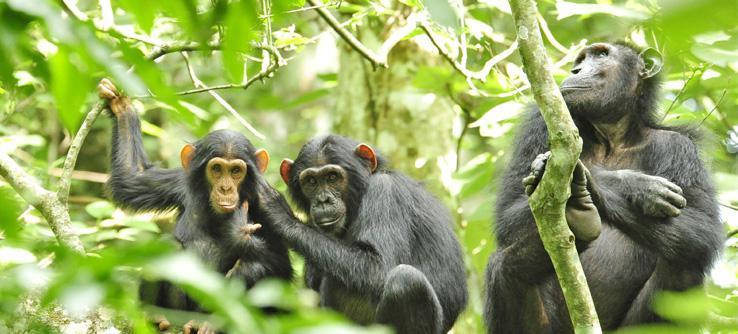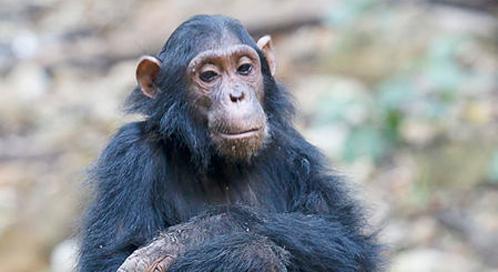The first image is the image on the left, the second image is the image on the right. For the images displayed, is the sentence "There are four apes" factually correct? Answer yes or no. Yes. 